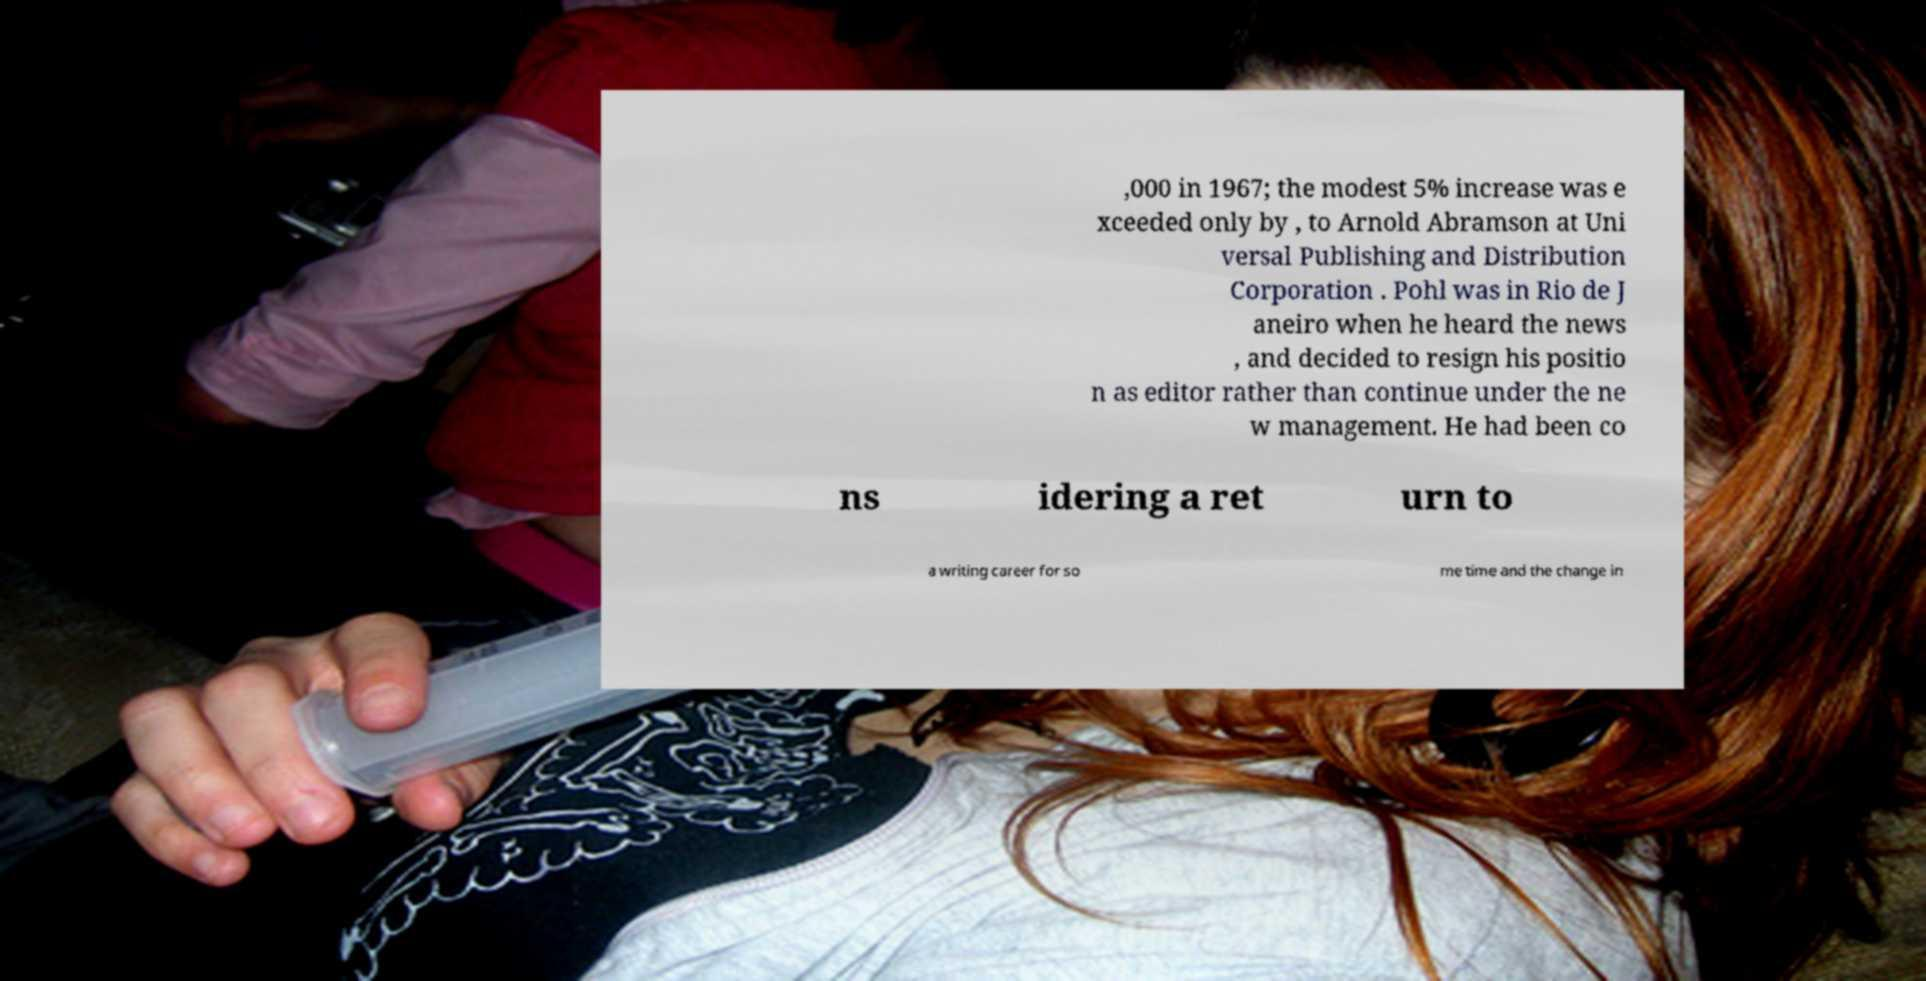I need the written content from this picture converted into text. Can you do that? ,000 in 1967; the modest 5% increase was e xceeded only by , to Arnold Abramson at Uni versal Publishing and Distribution Corporation . Pohl was in Rio de J aneiro when he heard the news , and decided to resign his positio n as editor rather than continue under the ne w management. He had been co ns idering a ret urn to a writing career for so me time and the change in 